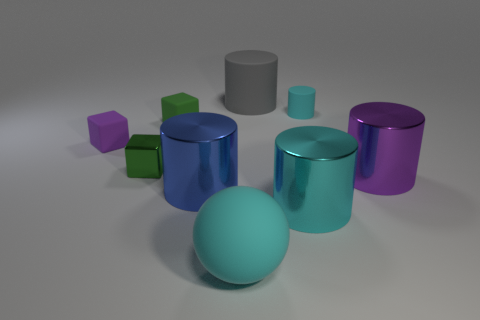Is the purple metal thing the same shape as the gray rubber thing? Yes, the purple metal object and the gray rubber object both have a cylindrical shape, characterized by their circular bases and extended straight sides. While the materials and possibly the size look different with the purple object having a metallic sheen and the gray object appearing to be made of rubber, the core geometric shape is the same for both. 